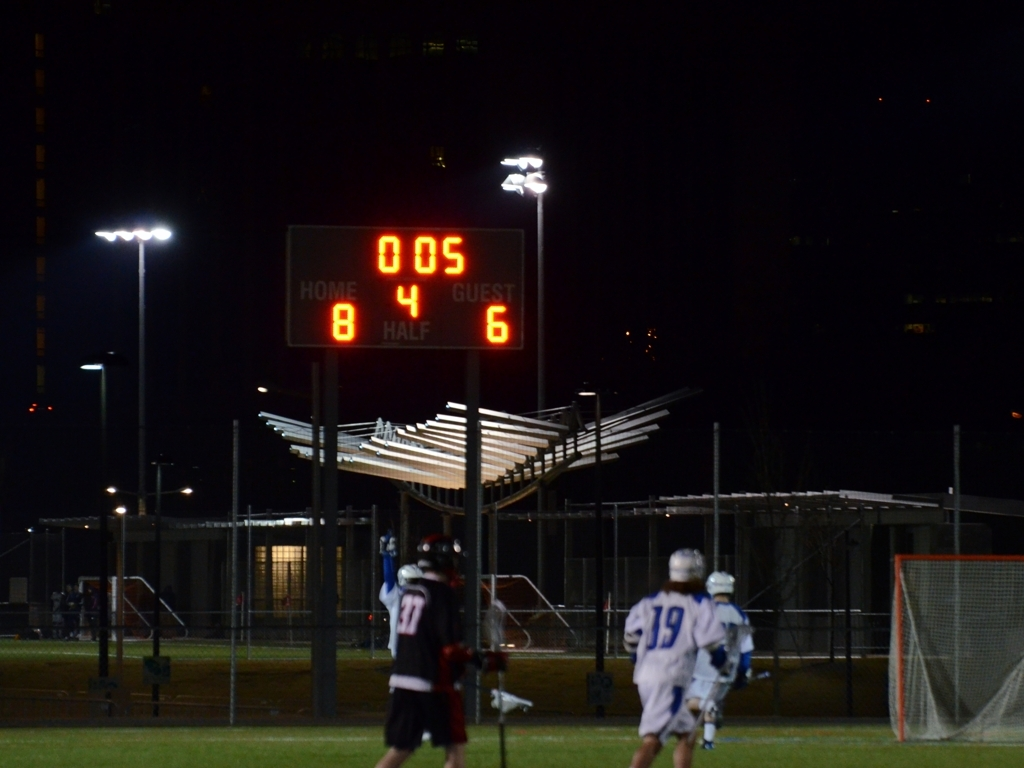What might be significant about the moment captured in this image? The scoreboard indicates that there are only 5 seconds remaining in the match's half, with the home team leading, which suggests a tense, climactic moment of the game. This snapshot in time could represent a critical point where strategy and skill are crucial for both teams. 